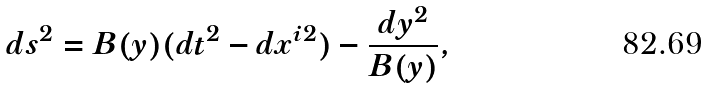Convert formula to latex. <formula><loc_0><loc_0><loc_500><loc_500>d s ^ { 2 } = B ( y ) ( d t ^ { 2 } - d x ^ { i 2 } ) - \frac { d y ^ { 2 } } { B ( y ) } ,</formula> 